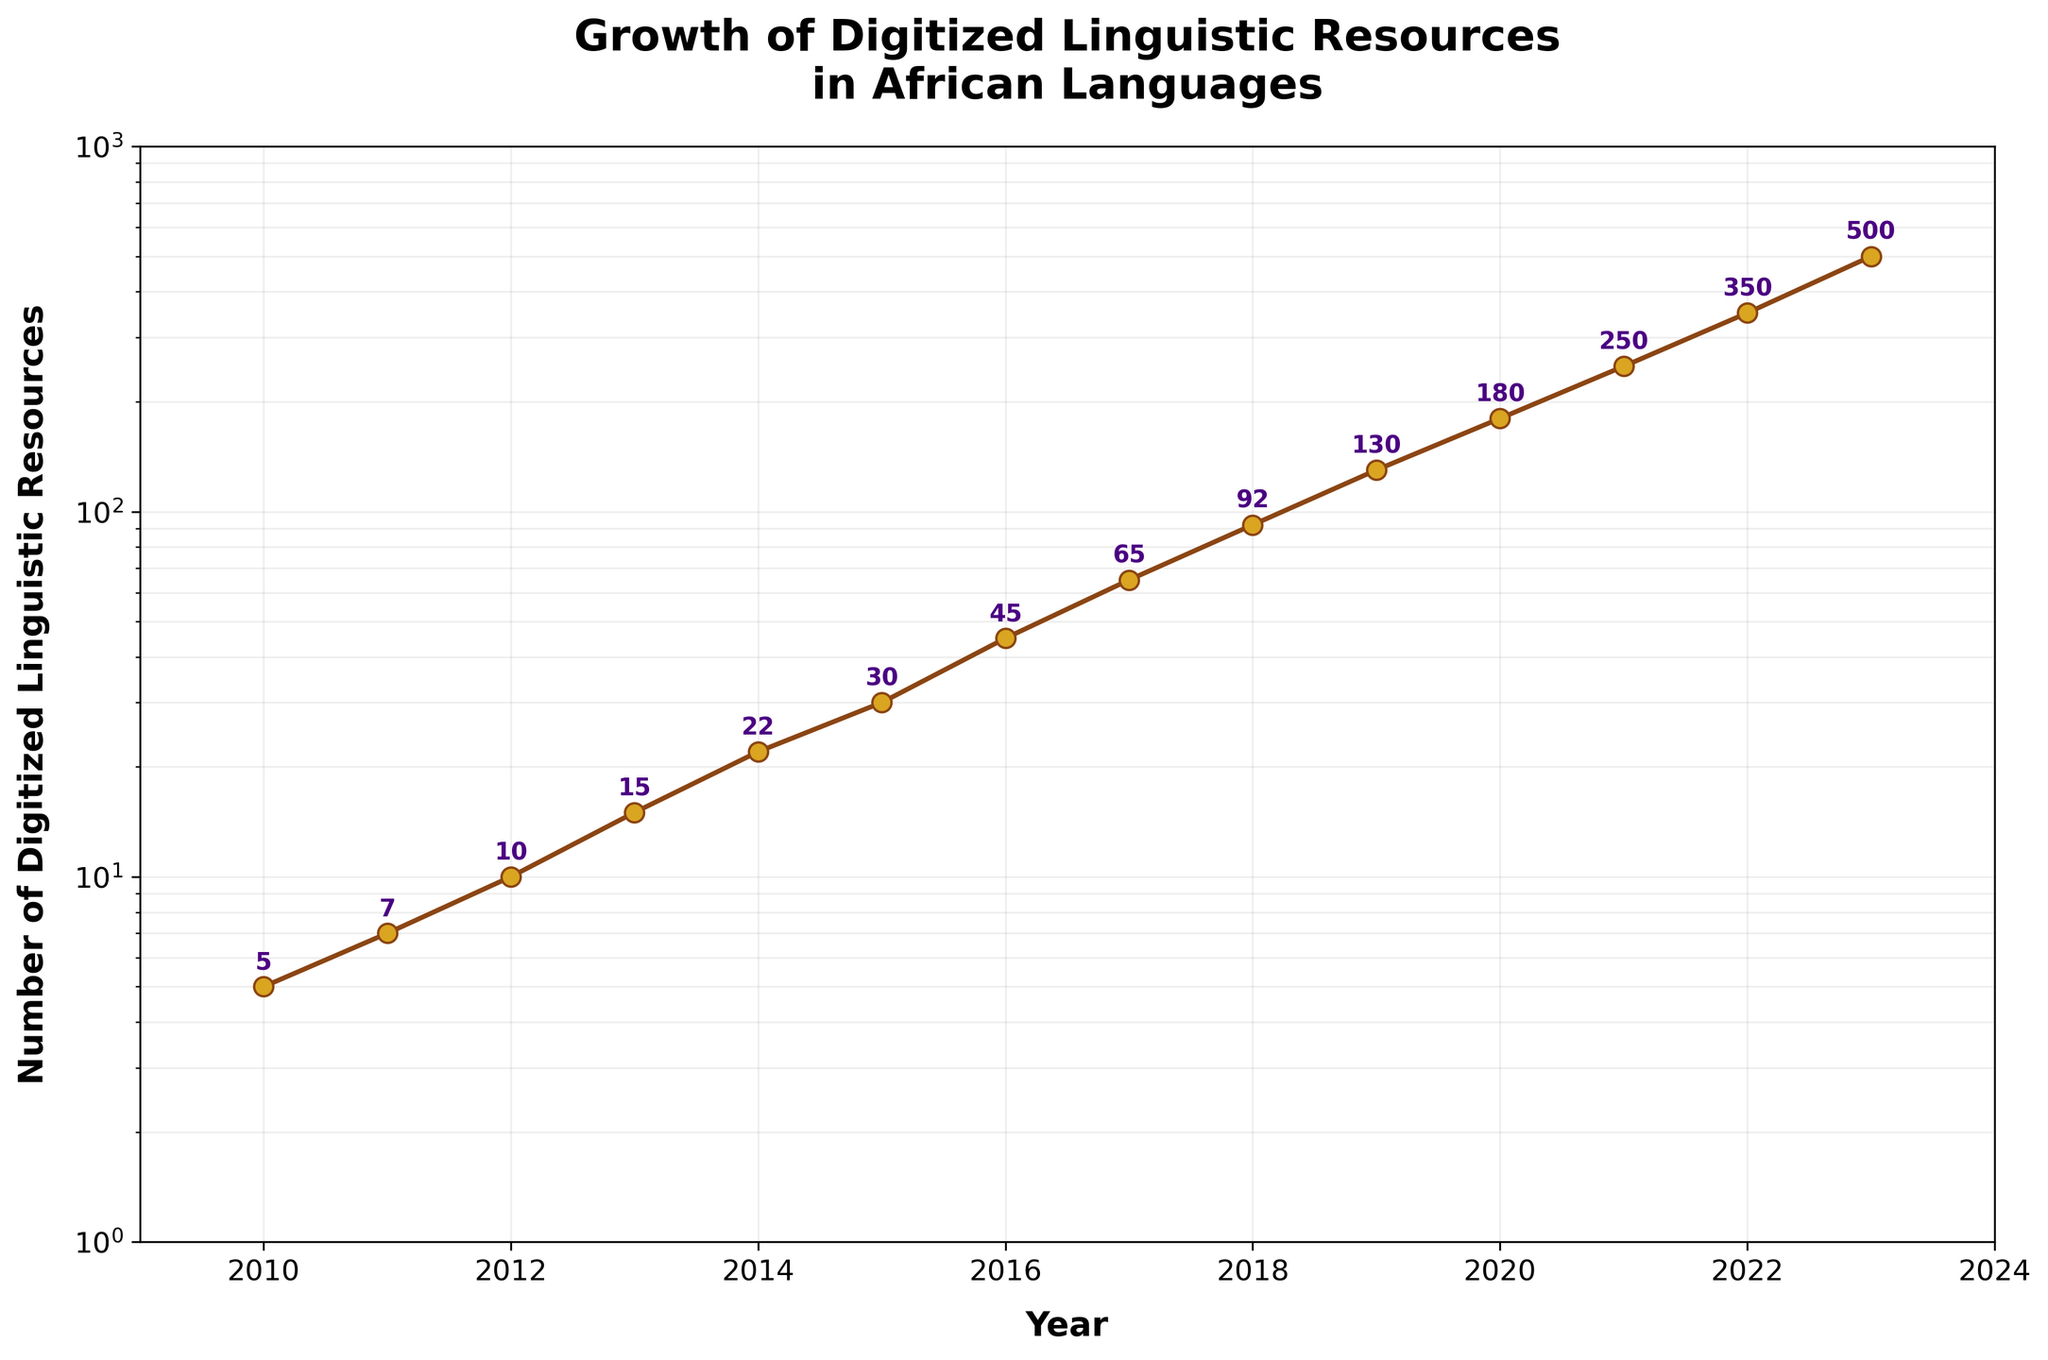What is the title of the plot? The title is usually found at the top of the plot. Here, it reads, "Growth of Digitized Linguistic Resources\nin African Languages".
Answer: Growth of Digitized Linguistic Resources in African Languages What is used as the vertical scale of the plot? The vertical scale in this plot is logarithmic, meaning each interval is a power of ten. This can be seen by the way the axis labels change multiplicatively.
Answer: Logarithmic How many data points are shown between the years 2010 and 2023? You simply count the number of points plotted on the line between the years 2010 and 2023 (inclusive). There is one point for each year.
Answer: 14 Which year saw the highest number of digitized linguistic resources? To find this, look for the highest point on the plot. The annotated number near the highest point indicates that 2023 saw the highest number of digitized resources, which is 500.
Answer: 2023 How many digitized linguistic resources were there in 2018? Find the year 2018 on the horizontal axis and look vertically up to the corresponding data point. The annotated number there is 92.
Answer: 92 By how much did the number of resources increase from 2015 to 2018? The number of resources in 2015 was 30, and in 2018 it was 92. To find the increase, subtract the former from the latter: 92 - 30 = 62.
Answer: 62 On average, how many resources were added each year between 2016 and 2021 (inclusive)? Between 2016 and 2021, the number of resources each year were 45, 65, 92, 130, 180, 250. Add these numbers and divide by the number of years (6): (45 + 65 + 92 + 130 + 180 + 250) / 6 ≈ 127.
Answer: 127 Compare the rate of growth between the periods 2010-2015 and 2015-2020. Which period had a faster rate of increase? From 2010 to 2015, resources grew from 5 to 30 (an increase of 25). From 2015 to 2020, resources grew from 30 to 180 (an increase of 150). For each period of 5 years, the absolute growth was larger in the latter period.
Answer: 2015-2020 What can you infer from the shape of the growth curve when viewed on a logarithmic scale? The curve's shape on a logarithmic scale suggests exponential growth of the number of digitized linguistic resources, as the line approximates a straight line on a log scale.
Answer: Exponential growth Is the overall visual trend upward or downward over the years? Observing the plot from left to right, the line generally ascends, meaning an increase over time.
Answer: Upward 